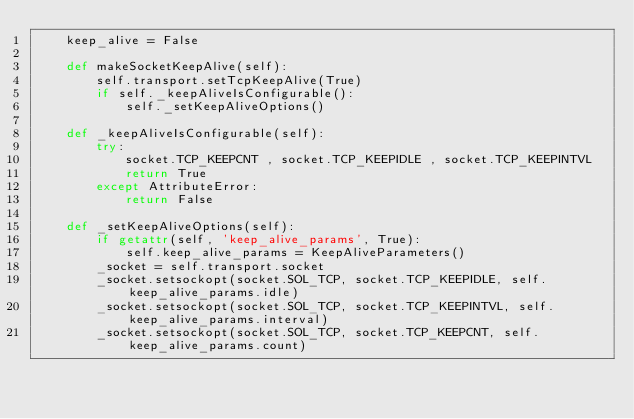<code> <loc_0><loc_0><loc_500><loc_500><_Python_>	keep_alive = False

	def makeSocketKeepAlive(self):
		self.transport.setTcpKeepAlive(True)
		if self._keepAliveIsConfigurable():
			self._setKeepAliveOptions()

	def _keepAliveIsConfigurable(self):
		try:
			socket.TCP_KEEPCNT , socket.TCP_KEEPIDLE , socket.TCP_KEEPINTVL
			return True
		except AttributeError:
			return False

	def _setKeepAliveOptions(self):
		if getattr(self, 'keep_alive_params', True):
			self.keep_alive_params = KeepAliveParameters()
		_socket = self.transport.socket
		_socket.setsockopt(socket.SOL_TCP, socket.TCP_KEEPIDLE, self.keep_alive_params.idle)
		_socket.setsockopt(socket.SOL_TCP, socket.TCP_KEEPINTVL, self.keep_alive_params.interval)
		_socket.setsockopt(socket.SOL_TCP, socket.TCP_KEEPCNT, self.keep_alive_params.count)
</code> 